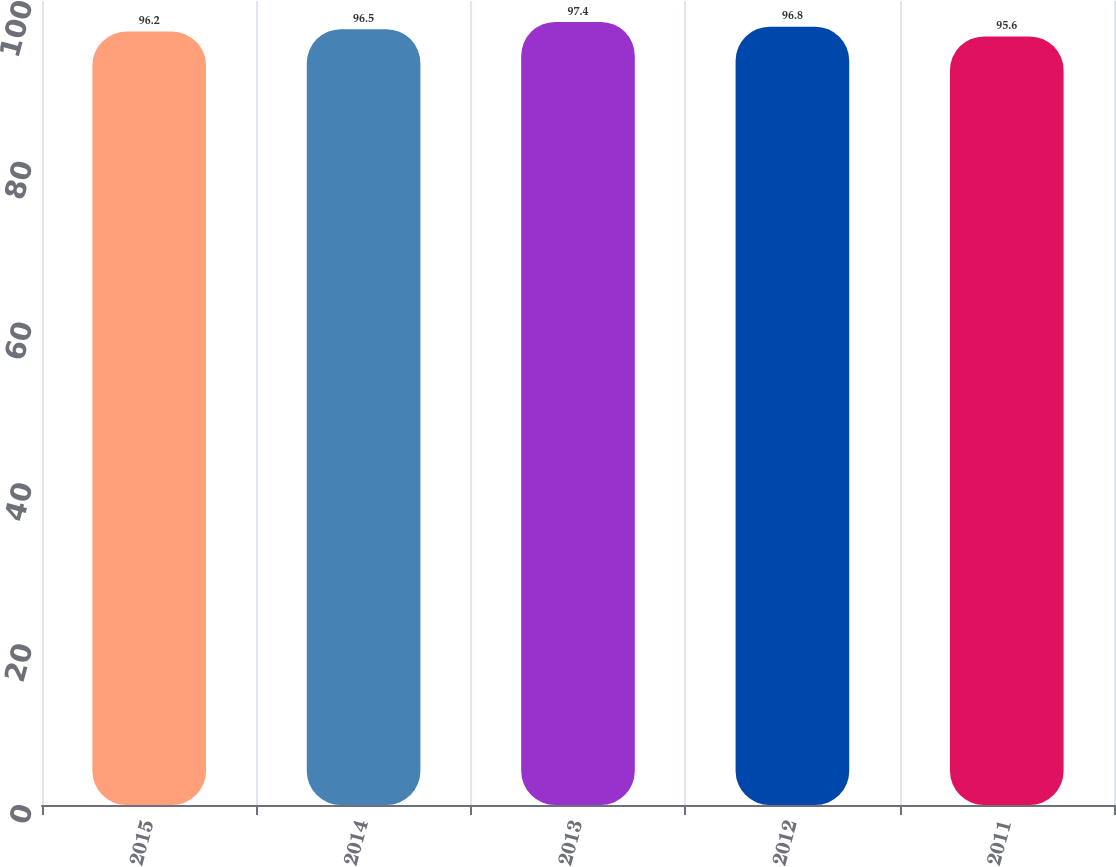Convert chart. <chart><loc_0><loc_0><loc_500><loc_500><bar_chart><fcel>2015<fcel>2014<fcel>2013<fcel>2012<fcel>2011<nl><fcel>96.2<fcel>96.5<fcel>97.4<fcel>96.8<fcel>95.6<nl></chart> 